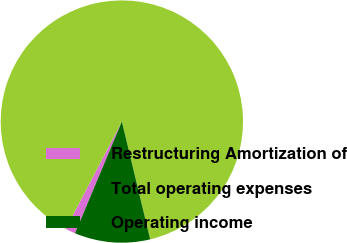<chart> <loc_0><loc_0><loc_500><loc_500><pie_chart><fcel>Restructuring Amortization of<fcel>Total operating expenses<fcel>Operating income<nl><fcel>1.35%<fcel>88.58%<fcel>10.07%<nl></chart> 